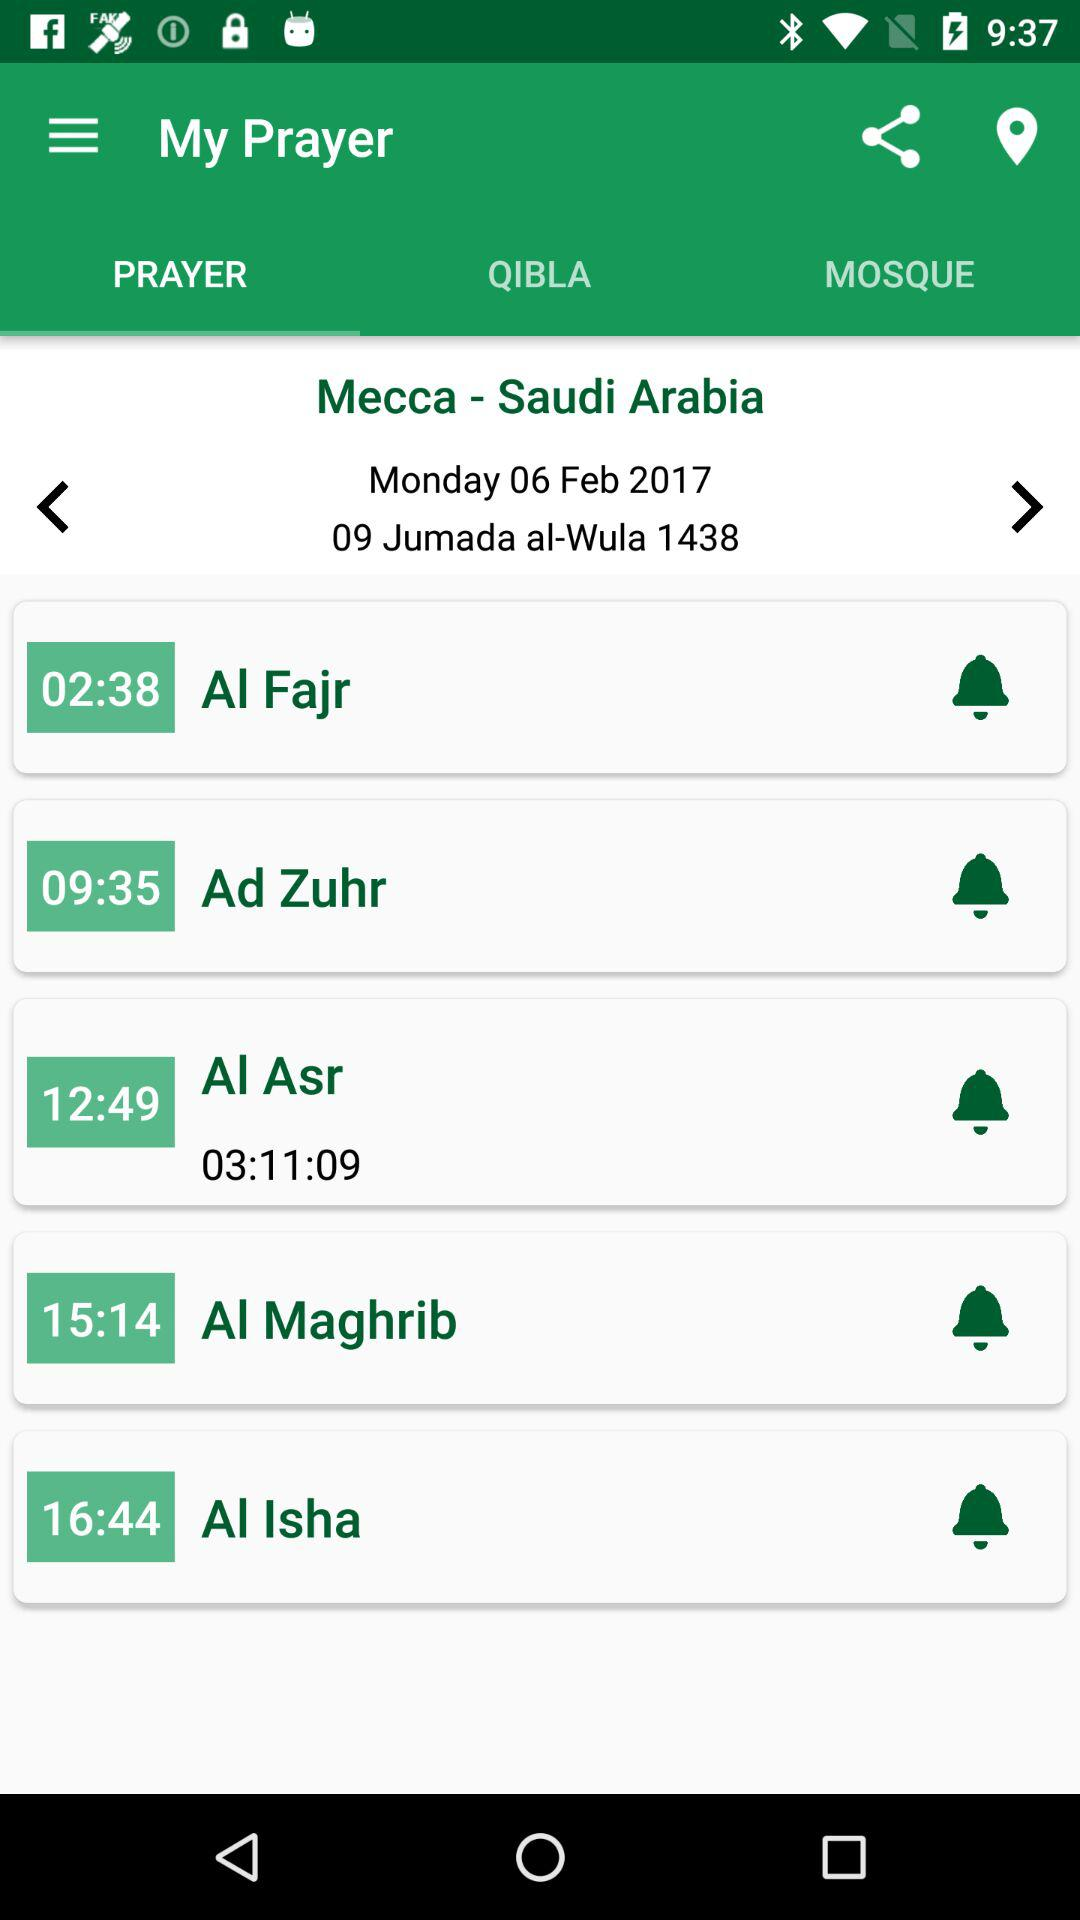What is the time of the "Ad Zuhr" prayer? The time is 09:35. 